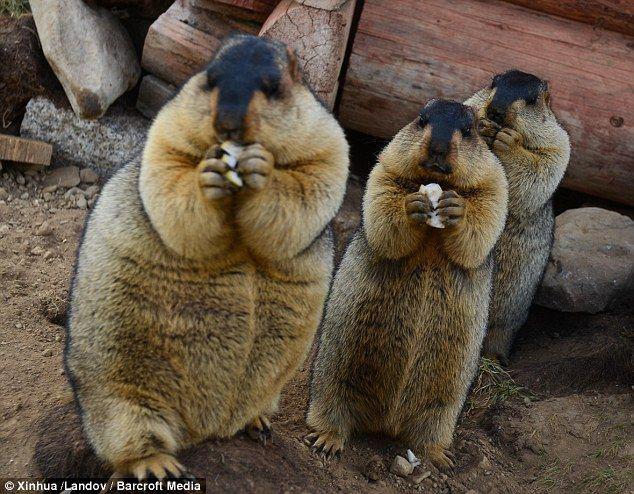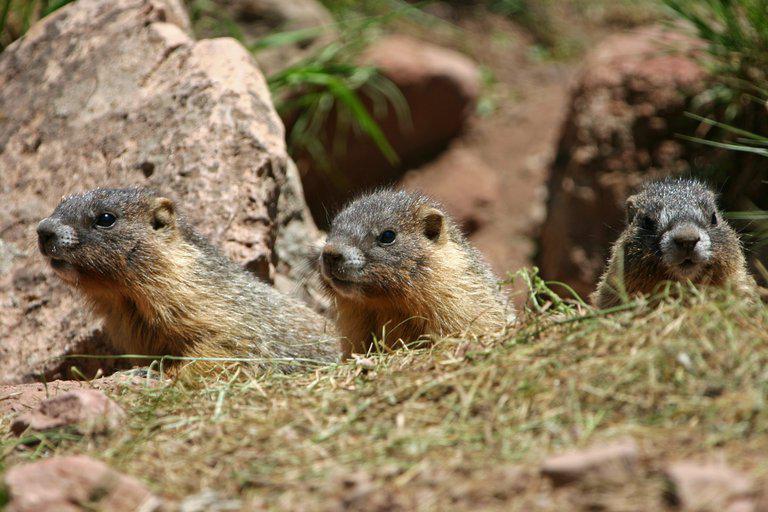The first image is the image on the left, the second image is the image on the right. For the images shown, is this caption "The left image includes at least one marmot standing on its hind legs and clutching a piece of food near its mouth with both front paws." true? Answer yes or no. Yes. 